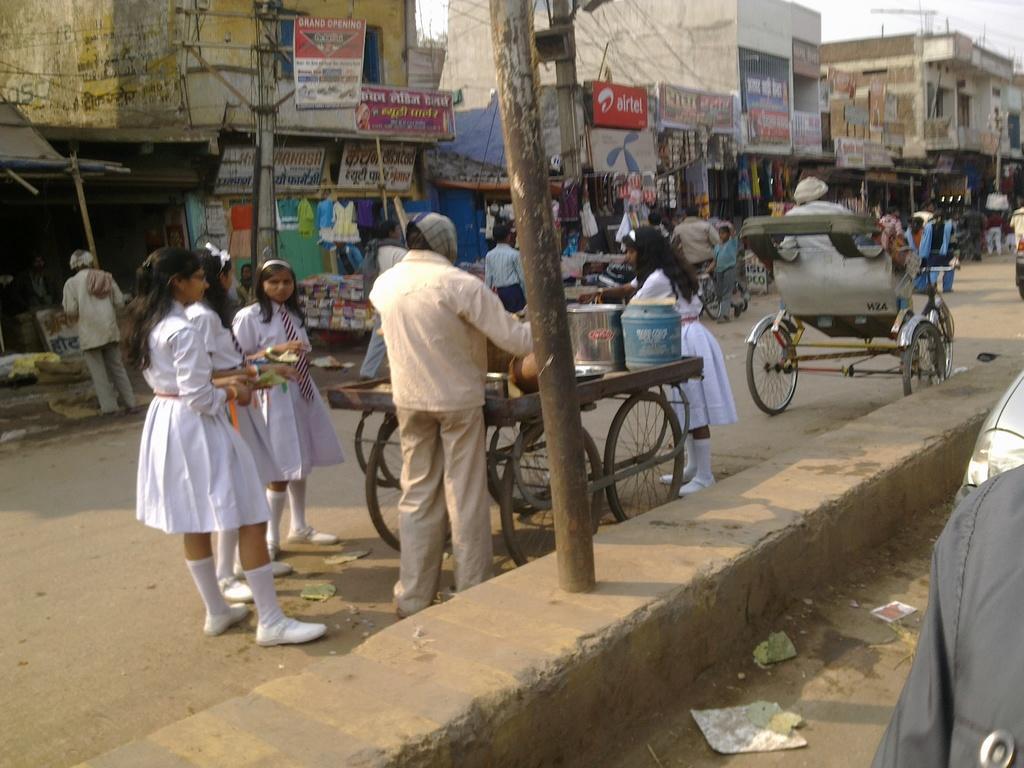Please provide a concise description of this image. In this image there is the sky truncated towards the top of the image, there are buildings truncated towards the top of the image, there is a building truncated towards the right of the image, there are objects truncated towards the right of the image, there is an object truncated towards the left of the image, there are groups of persons, there is road truncated towards the left of the image, there are persons holding an object, there are boards, there is text on the boards, there are poles truncated towards the top of the image, there are vehicles on the road, there are objects on the ground. 